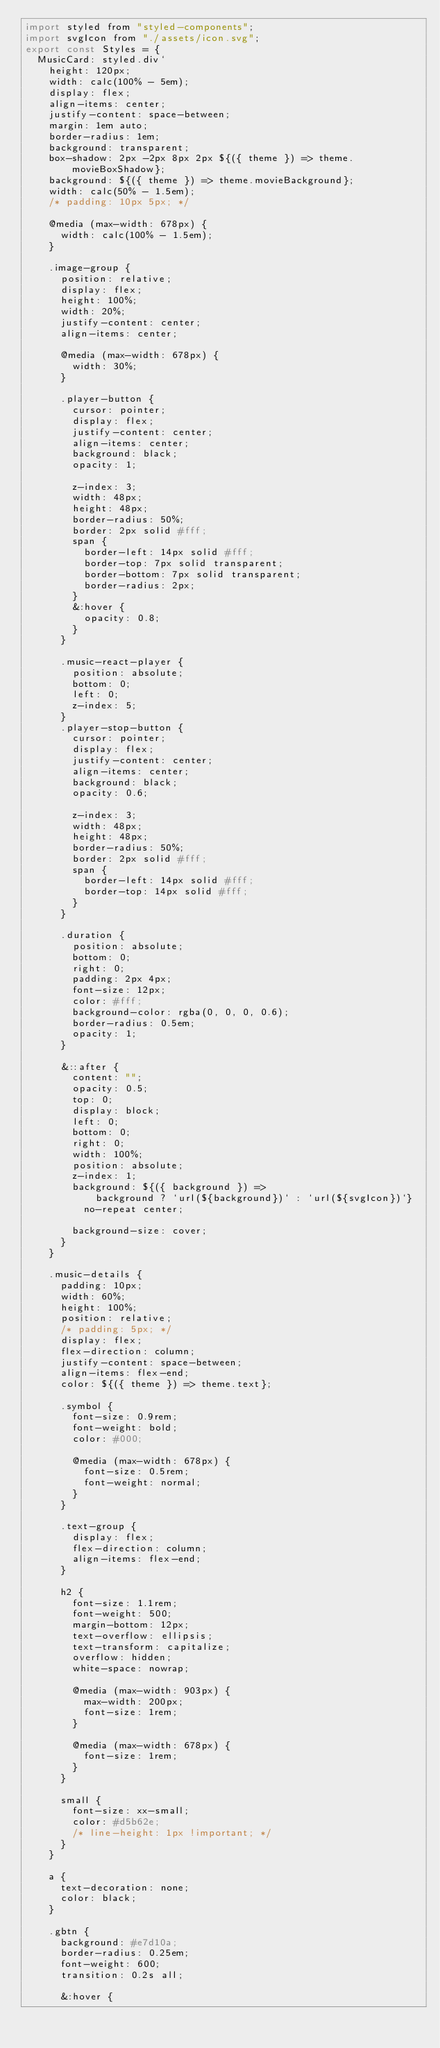<code> <loc_0><loc_0><loc_500><loc_500><_JavaScript_>import styled from "styled-components";
import svgIcon from "./assets/icon.svg";
export const Styles = {
  MusicCard: styled.div`
    height: 120px;
    width: calc(100% - 5em);
    display: flex;
    align-items: center;
    justify-content: space-between;
    margin: 1em auto;
    border-radius: 1em;
    background: transparent;
    box-shadow: 2px -2px 8px 2px ${({ theme }) => theme.movieBoxShadow};
    background: ${({ theme }) => theme.movieBackground};
    width: calc(50% - 1.5em);
    /* padding: 10px 5px; */

    @media (max-width: 678px) {
      width: calc(100% - 1.5em);
    }

    .image-group {
      position: relative;
      display: flex;
      height: 100%;
      width: 20%;
      justify-content: center;
      align-items: center;

      @media (max-width: 678px) {
        width: 30%;
      }

      .player-button {
        cursor: pointer;
        display: flex;
        justify-content: center;
        align-items: center;
        background: black;
        opacity: 1;

        z-index: 3;
        width: 48px;
        height: 48px;
        border-radius: 50%;
        border: 2px solid #fff;
        span {
          border-left: 14px solid #fff;
          border-top: 7px solid transparent;
          border-bottom: 7px solid transparent;
          border-radius: 2px;
        }
        &:hover {
          opacity: 0.8;
        }
      }

      .music-react-player {
        position: absolute;
        bottom: 0;
        left: 0;
        z-index: 5;
      }
      .player-stop-button {
        cursor: pointer;
        display: flex;
        justify-content: center;
        align-items: center;
        background: black;
        opacity: 0.6;

        z-index: 3;
        width: 48px;
        height: 48px;
        border-radius: 50%;
        border: 2px solid #fff;
        span {
          border-left: 14px solid #fff;
          border-top: 14px solid #fff;
        }
      }

      .duration {
        position: absolute;
        bottom: 0;
        right: 0;
        padding: 2px 4px;
        font-size: 12px;
        color: #fff;
        background-color: rgba(0, 0, 0, 0.6);
        border-radius: 0.5em;
        opacity: 1;
      }

      &::after {
        content: "";
        opacity: 0.5;
        top: 0;
        display: block;
        left: 0;
        bottom: 0;
        right: 0;
        width: 100%;
        position: absolute;
        z-index: 1;
        background: ${({ background }) =>
            background ? `url(${background})` : `url(${svgIcon})`}
          no-repeat center;

        background-size: cover;
      }
    }

    .music-details {
      padding: 10px;
      width: 60%;
      height: 100%;
      position: relative;
      /* padding: 5px; */
      display: flex;
      flex-direction: column;
      justify-content: space-between;
      align-items: flex-end;
      color: ${({ theme }) => theme.text};

      .symbol {
        font-size: 0.9rem;
        font-weight: bold;
        color: #000;

        @media (max-width: 678px) {
          font-size: 0.5rem;
          font-weight: normal;
        }
      }

      .text-group {
        display: flex;
        flex-direction: column;
        align-items: flex-end;
      }

      h2 {
        font-size: 1.1rem;
        font-weight: 500;
        margin-bottom: 12px;
        text-overflow: ellipsis;
        text-transform: capitalize;
        overflow: hidden;
        white-space: nowrap;

        @media (max-width: 903px) {
          max-width: 200px;
          font-size: 1rem;
        }

        @media (max-width: 678px) {
          font-size: 1rem;
        }
      }

      small {
        font-size: xx-small;
        color: #d5b62e;
        /* line-height: 1px !important; */
      }
    }

    a {
      text-decoration: none;
      color: black;
    }

    .gbtn {
      background: #e7d10a;
      border-radius: 0.25em;
      font-weight: 600;
      transition: 0.2s all;

      &:hover {</code> 